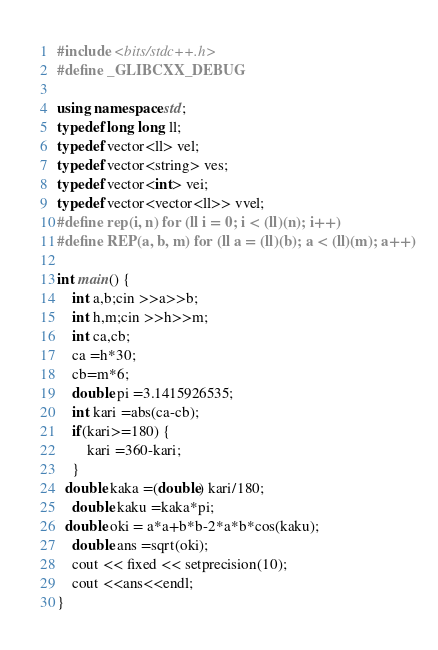<code> <loc_0><loc_0><loc_500><loc_500><_C++_>#include <bits/stdc++.h>
#define _GLIBCXX_DEBUG

using namespace std;
typedef long long ll;
typedef vector<ll> vel;
typedef vector<string> ves;
typedef vector<int> vei;
typedef vector<vector<ll>> vvel;
#define rep(i, n) for (ll i = 0; i < (ll)(n); i++)
#define REP(a, b, m) for (ll a = (ll)(b); a < (ll)(m); a++)

int main() {
    int a,b;cin >>a>>b;
    int h,m;cin >>h>>m;
    int ca,cb;
    ca =h*30;
    cb=m*6;
    double pi =3.1415926535;
    int kari =abs(ca-cb);
    if(kari>=180) {
        kari =360-kari;
    }
  double kaka =(double) kari/180;
    double kaku =kaka*pi;
  double oki = a*a+b*b-2*a*b*cos(kaku);
    double ans =sqrt(oki);
    cout << fixed << setprecision(10);
    cout <<ans<<endl;
}</code> 